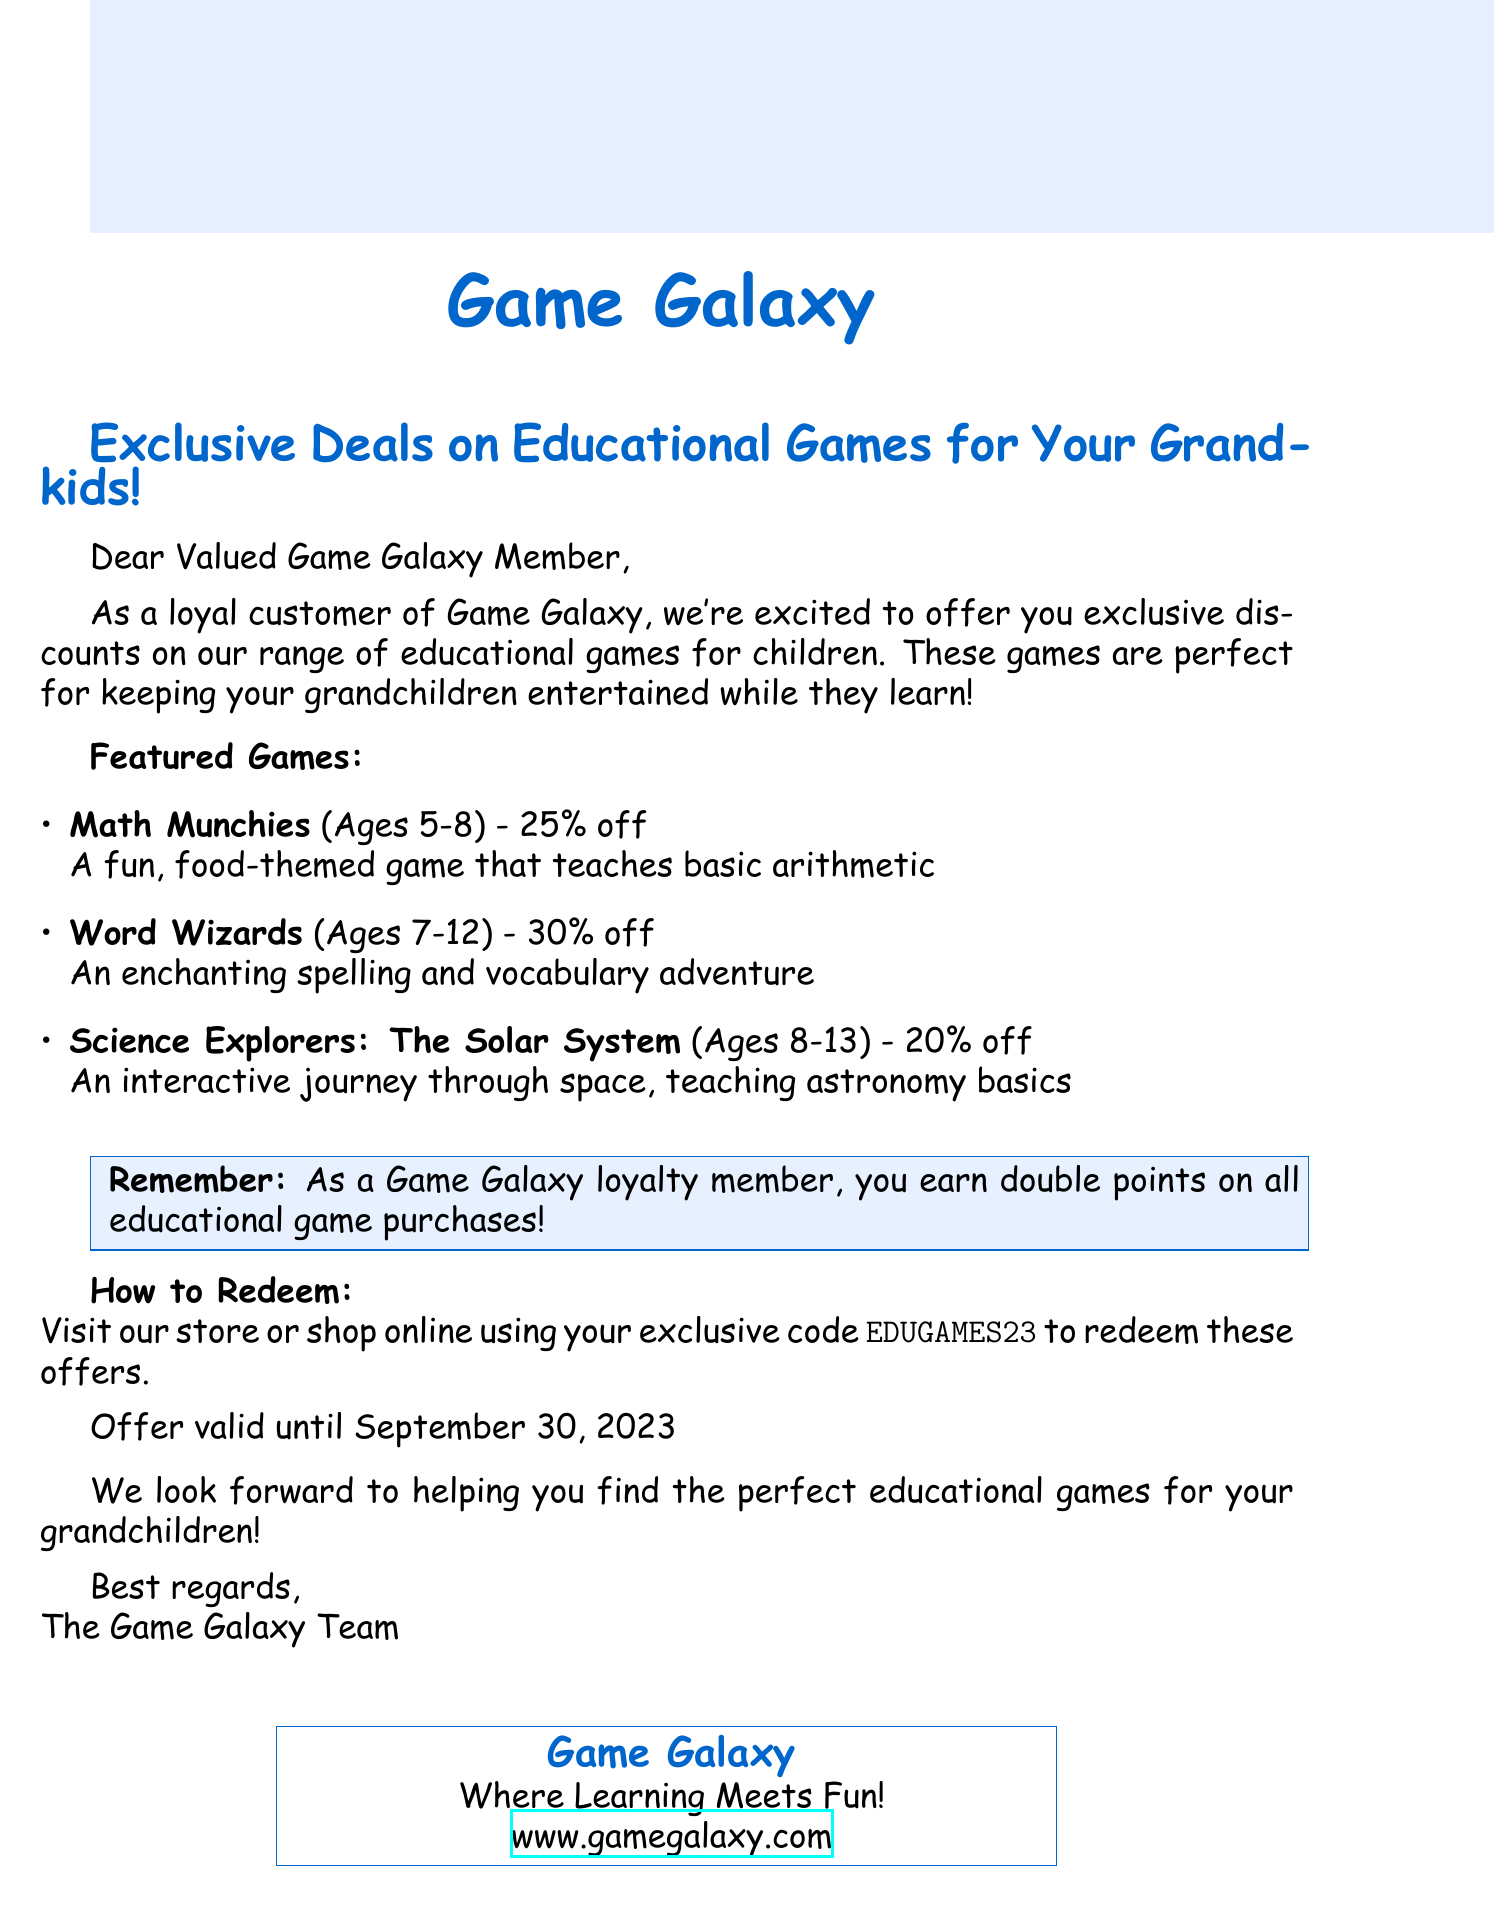What is the subject line of the email? The subject line is the heading that summarizes the main offering of the email.
Answer: Exclusive Deals on Educational Games for Your Grandkids! What discount is offered for "Word Wizards"? The discount for each featured game is mentioned, providing specific savings for them.
Answer: 30% off What age range is "Math Munchies" suitable for? The age range tells which children the game is designed for, helping to recommend it appropriately.
Answer: 5-8 years When does the offer expire? The expiration date indicates how long the promotional deal will be available for members.
Answer: September 30, 2023 What is the exclusive code to redeem the offers? The exclusive code is a specific detail provided for customers to claim their discounts online or in-store.
Answer: EDUGAMES23 How many points do loyalty members earn on educational game purchases? This reinforces the value of being a loyalty member and incentivizes purchases of educational games.
Answer: double points What type of games are being promoted in the email? The type of games helps to understand the focus of the promotion and its benefits for children.
Answer: Educational games What is the main purpose of the email? The purpose explains why the email was sent and the value it aims to offer to recipients.
Answer: Offer exclusive discounts on educational games 